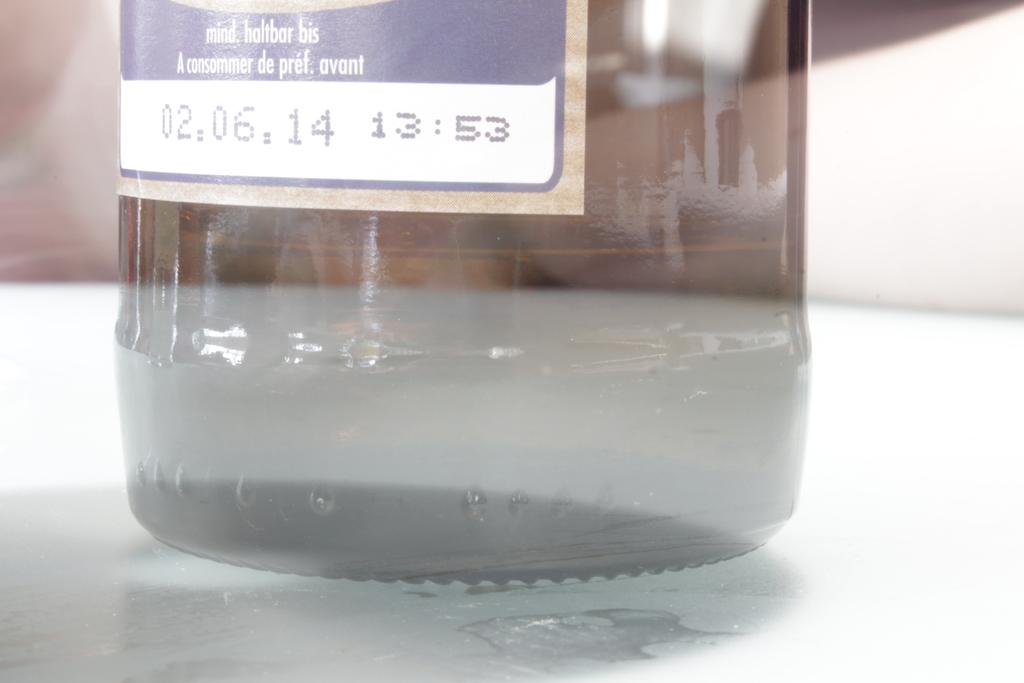<image>
Present a compact description of the photo's key features. A label on a bottle warns to consume the product before 02.06.14 